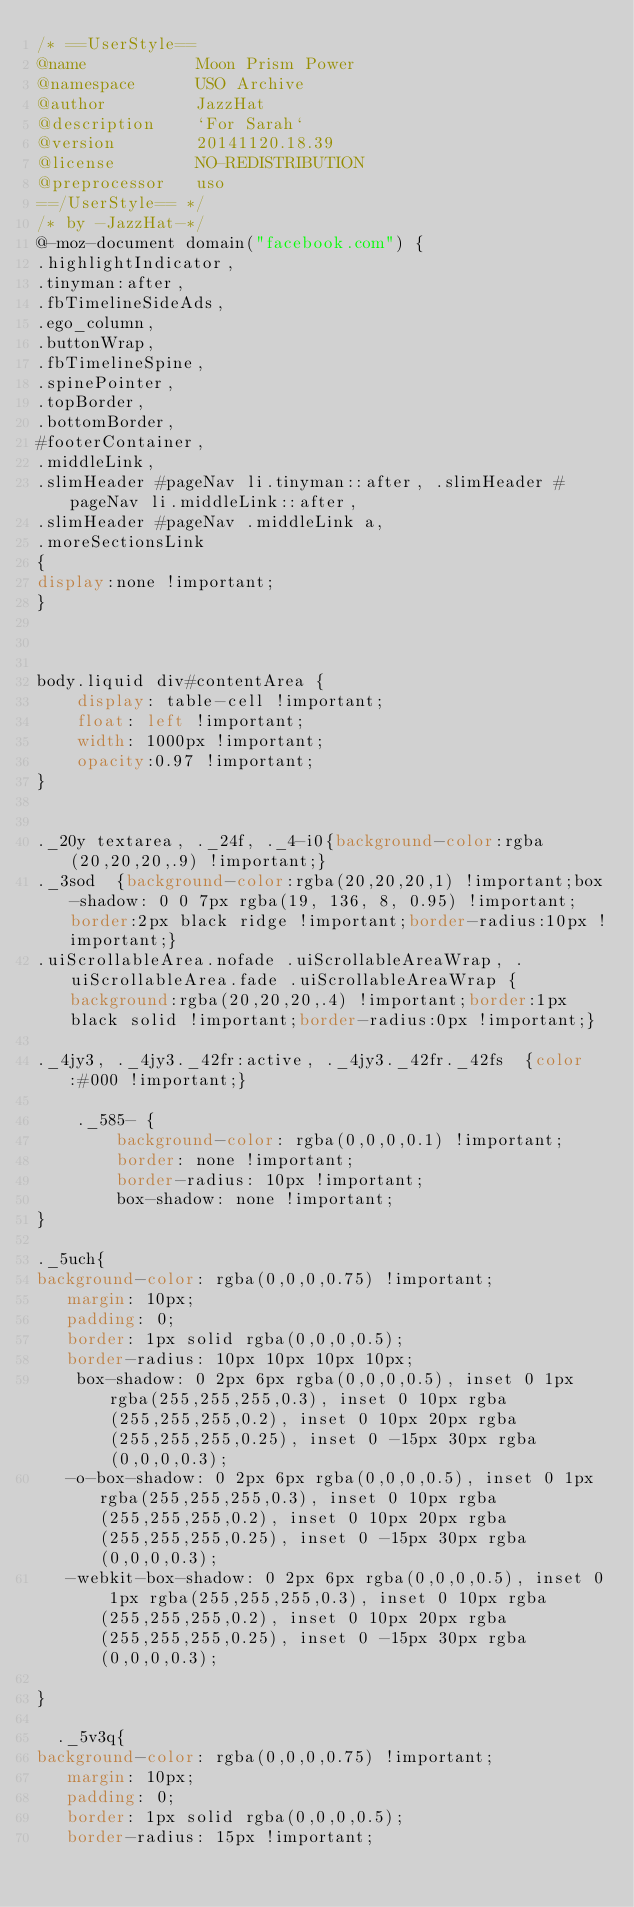Convert code to text. <code><loc_0><loc_0><loc_500><loc_500><_CSS_>/* ==UserStyle==
@name           Moon Prism Power
@namespace      USO Archive
@author         JazzHat
@description    `For Sarah`
@version        20141120.18.39
@license        NO-REDISTRIBUTION
@preprocessor   uso
==/UserStyle== */
/* by -JazzHat-*/
@-moz-document domain("facebook.com") {
.highlightIndicator, 
.tinyman:after, 
.fbTimelineSideAds,
.ego_column,
.buttonWrap, 
.fbTimelineSpine, 
.spinePointer, 
.topBorder, 
.bottomBorder, 
#footerContainer, 
.middleLink, 
.slimHeader #pageNav li.tinyman::after, .slimHeader #pageNav li.middleLink::after, 
.slimHeader #pageNav .middleLink a, 
.moreSectionsLink
{
display:none !important;
}

   
    
body.liquid div#contentArea {
    display: table-cell !important;
    float: left !important;
    width: 1000px !important;
    opacity:0.97 !important;
}


._20y textarea, ._24f, ._4-i0{background-color:rgba(20,20,20,.9) !important;}
._3sod  {background-color:rgba(20,20,20,1) !important;box-shadow: 0 0 7px rgba(19, 136, 8, 0.95) !important;border:2px black ridge !important;border-radius:10px !important;}
.uiScrollableArea.nofade .uiScrollableAreaWrap, .uiScrollableArea.fade .uiScrollableAreaWrap {background:rgba(20,20,20,.4) !important;border:1px black solid !important;border-radius:0px !important;}

._4jy3, ._4jy3._42fr:active, ._4jy3._42fr._42fs  {color:#000 !important;}

    ._585- {
        background-color: rgba(0,0,0,0.1) !important;
        border: none !important;
        border-radius: 10px !important;
        box-shadow: none !important;
}
    
._5uch{
background-color: rgba(0,0,0,0.75) !important;
   margin: 10px;
   padding: 0;
   border: 1px solid rgba(0,0,0,0.5);
   border-radius: 10px 10px 10px 10px;
    box-shadow: 0 2px 6px rgba(0,0,0,0.5), inset 0 1px rgba(255,255,255,0.3), inset 0 10px rgba(255,255,255,0.2), inset 0 10px 20px rgba(255,255,255,0.25), inset 0 -15px 30px rgba(0,0,0,0.3);
   -o-box-shadow: 0 2px 6px rgba(0,0,0,0.5), inset 0 1px rgba(255,255,255,0.3), inset 0 10px rgba(255,255,255,0.2), inset 0 10px 20px rgba(255,255,255,0.25), inset 0 -15px 30px rgba(0,0,0,0.3);
   -webkit-box-shadow: 0 2px 6px rgba(0,0,0,0.5), inset 0 1px rgba(255,255,255,0.3), inset 0 10px rgba(255,255,255,0.2), inset 0 10px 20px rgba(255,255,255,0.25), inset 0 -15px 30px rgba(0,0,0,0.3);

}

  ._5v3q{
background-color: rgba(0,0,0,0.75) !important;
   margin: 10px;
   padding: 0;
   border: 1px solid rgba(0,0,0,0.5);
   border-radius: 15px !important;</code> 